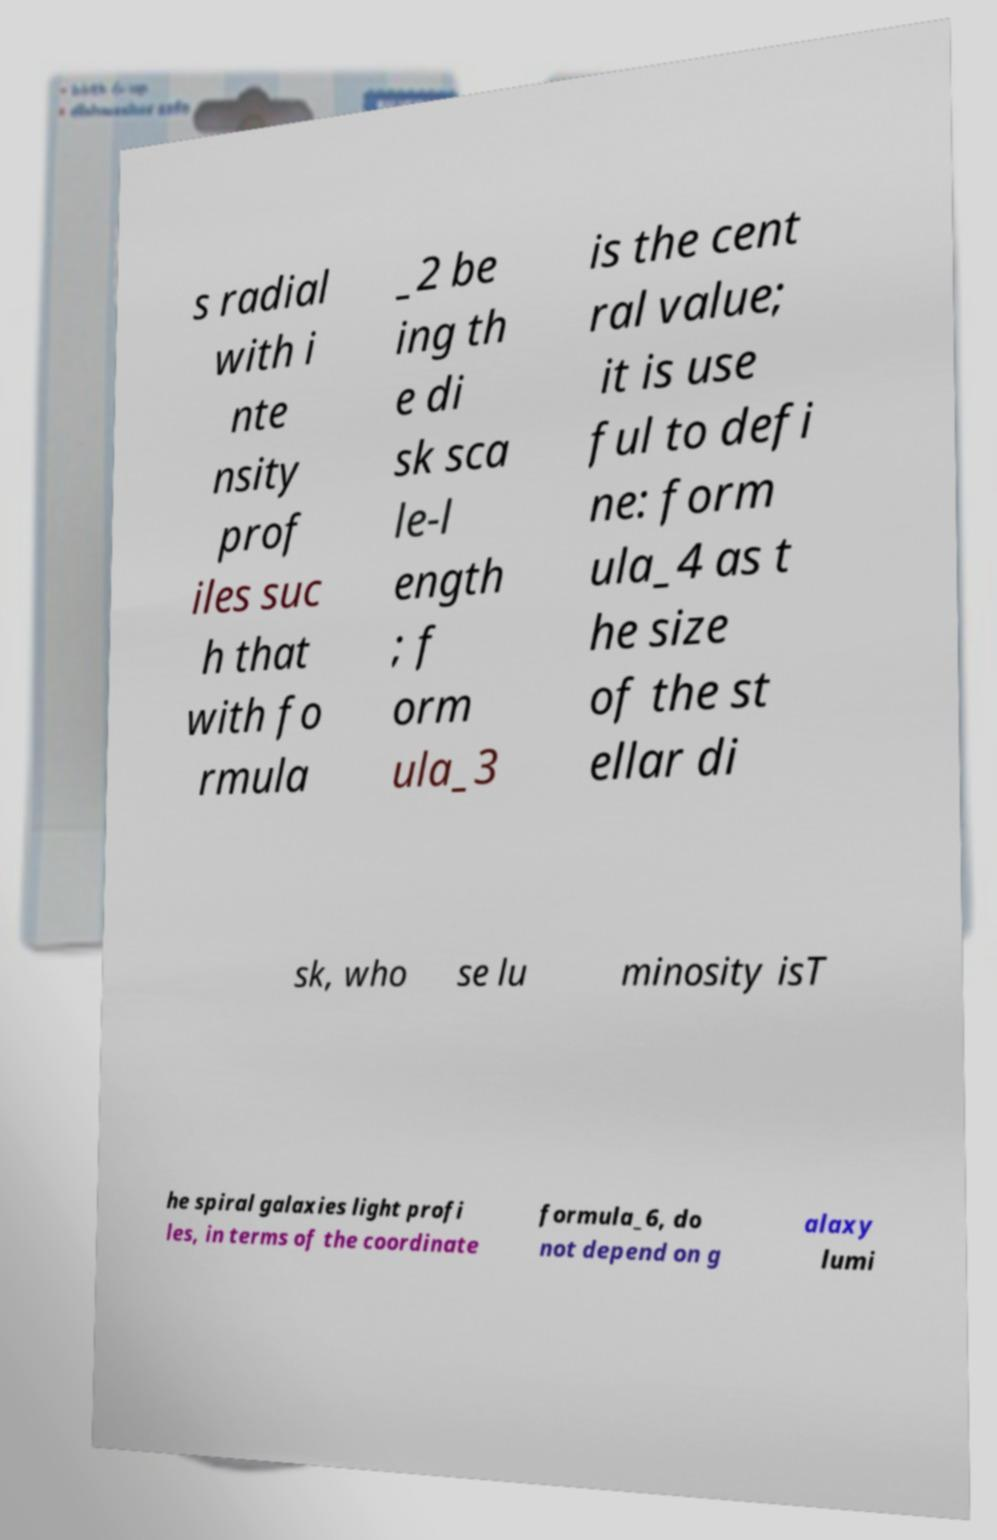What messages or text are displayed in this image? I need them in a readable, typed format. s radial with i nte nsity prof iles suc h that with fo rmula _2 be ing th e di sk sca le-l ength ; f orm ula_3 is the cent ral value; it is use ful to defi ne: form ula_4 as t he size of the st ellar di sk, who se lu minosity isT he spiral galaxies light profi les, in terms of the coordinate formula_6, do not depend on g alaxy lumi 